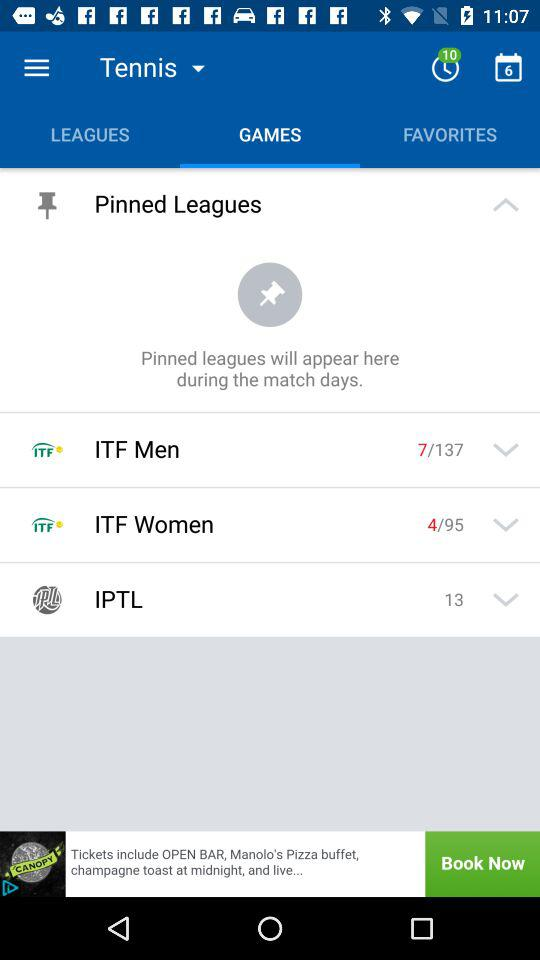How many unread notifications are on timer? The unread notifications are 10. 